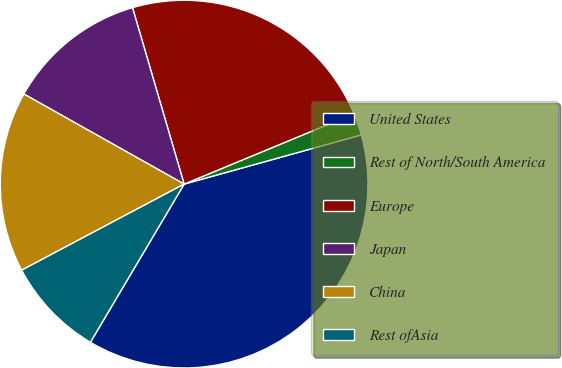<chart> <loc_0><loc_0><loc_500><loc_500><pie_chart><fcel>United States<fcel>Rest of North/South America<fcel>Europe<fcel>Japan<fcel>China<fcel>Rest ofAsia<nl><fcel>37.83%<fcel>1.94%<fcel>23.28%<fcel>12.32%<fcel>15.91%<fcel>8.73%<nl></chart> 